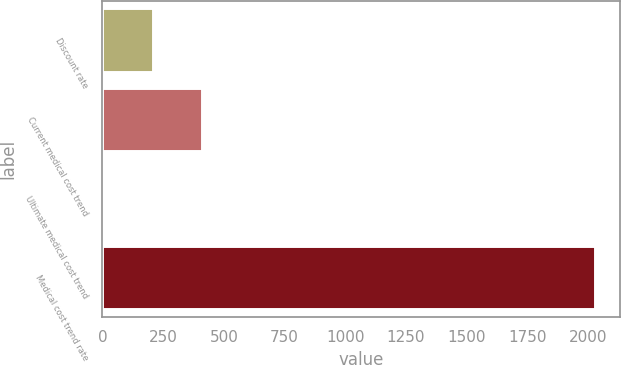<chart> <loc_0><loc_0><loc_500><loc_500><bar_chart><fcel>Discount rate<fcel>Current medical cost trend<fcel>Ultimate medical cost trend<fcel>Medical cost trend rate<nl><fcel>206.05<fcel>408.6<fcel>3.5<fcel>2029<nl></chart> 